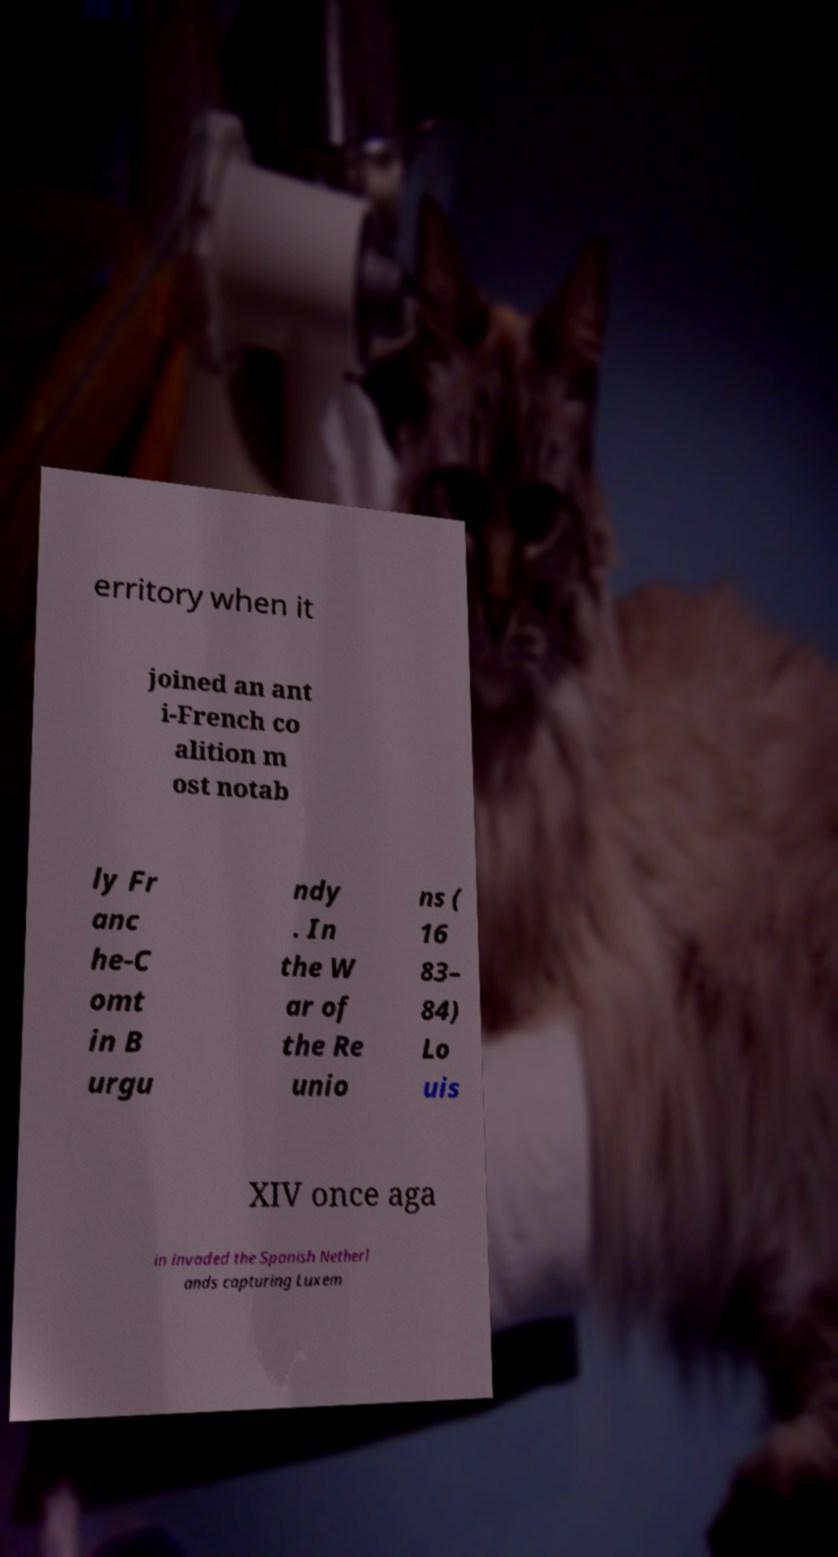What messages or text are displayed in this image? I need them in a readable, typed format. erritory when it joined an ant i-French co alition m ost notab ly Fr anc he-C omt in B urgu ndy . In the W ar of the Re unio ns ( 16 83– 84) Lo uis XIV once aga in invaded the Spanish Netherl ands capturing Luxem 